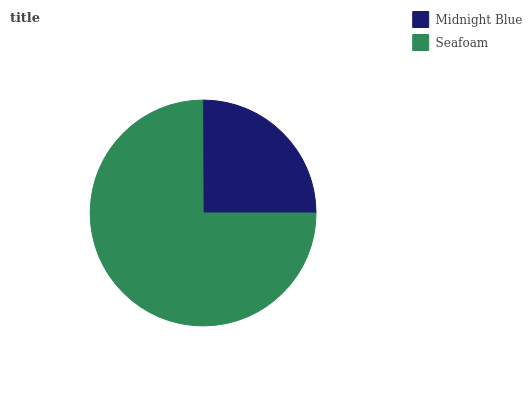Is Midnight Blue the minimum?
Answer yes or no. Yes. Is Seafoam the maximum?
Answer yes or no. Yes. Is Seafoam the minimum?
Answer yes or no. No. Is Seafoam greater than Midnight Blue?
Answer yes or no. Yes. Is Midnight Blue less than Seafoam?
Answer yes or no. Yes. Is Midnight Blue greater than Seafoam?
Answer yes or no. No. Is Seafoam less than Midnight Blue?
Answer yes or no. No. Is Seafoam the high median?
Answer yes or no. Yes. Is Midnight Blue the low median?
Answer yes or no. Yes. Is Midnight Blue the high median?
Answer yes or no. No. Is Seafoam the low median?
Answer yes or no. No. 